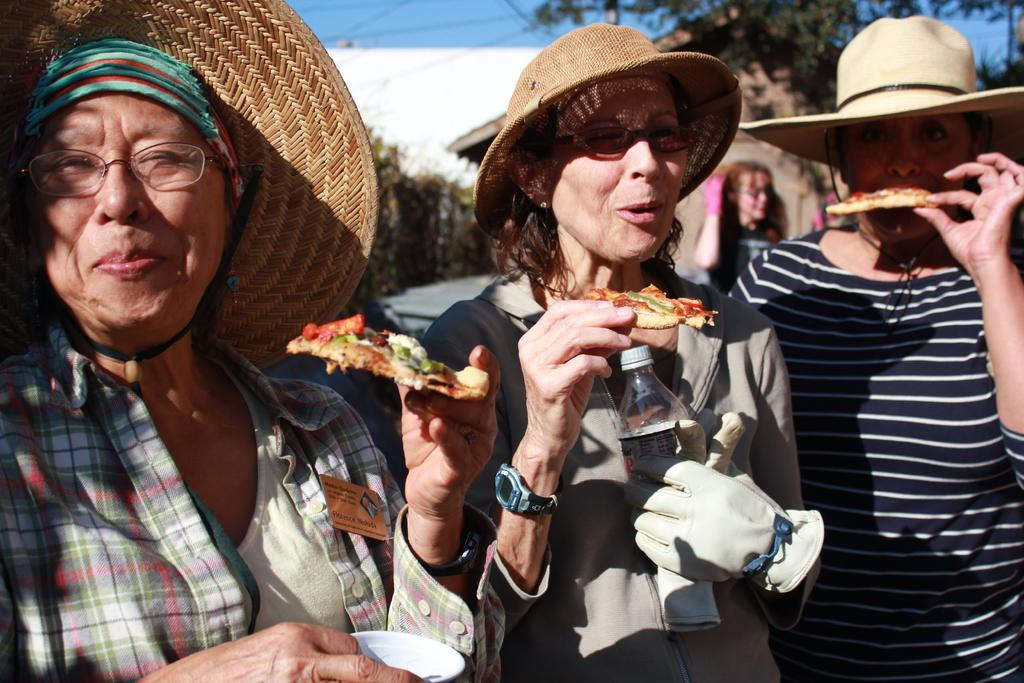What can be seen in the image? There is a group of women in the image. What are the women wearing? The women are wearing hats. What are the women doing in the image? The women are holding or eating some food item. What is visible in the background of the image? There are trees and the sky in the background of the image. Can you describe the sky in the image? The sky is clear and visible in the background of the image. How many soldiers are present in the image? There are no soldiers or army members present in the image; it features a group of women holding or eating some food item. 